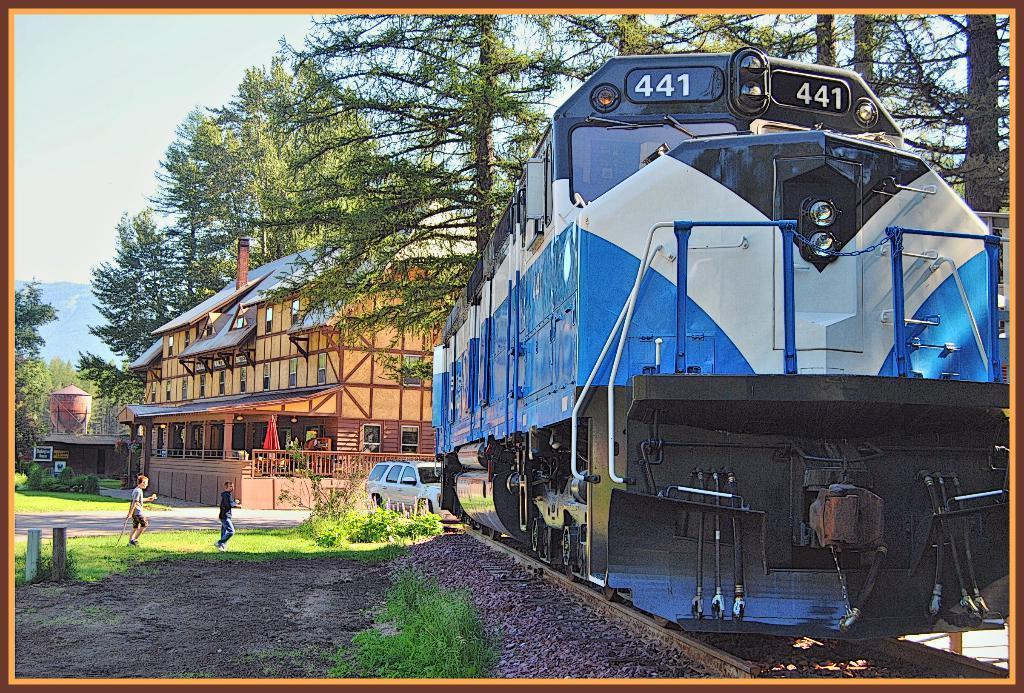Please provide a concise description of this image. In this image I can see railway tracks and on it I can see blue colour train. I can also see few numbers are written over here. In the background I can see a building, few trees, a vehicle, grass and I can see two people are standing. I can also see the sky in background. 